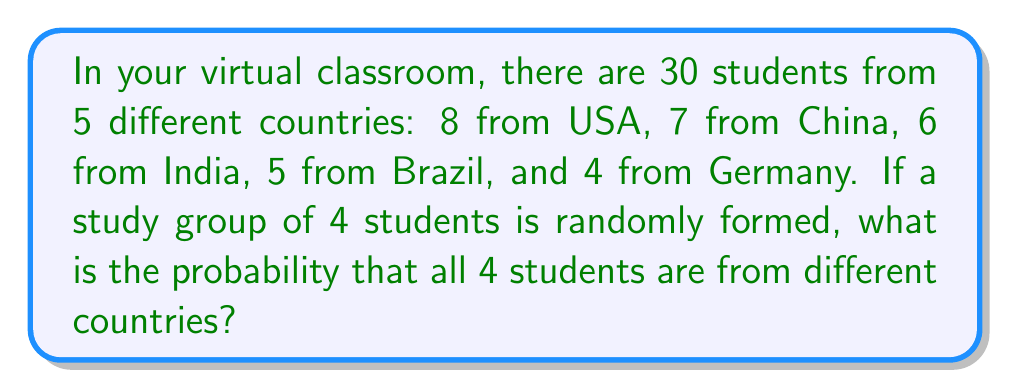Provide a solution to this math problem. Let's approach this step-by-step:

1) First, we need to calculate the total number of ways to choose 4 students out of 30. This is given by the combination formula:

   $$\binom{30}{4} = \frac{30!}{4!(30-4)!} = \frac{30!}{4!26!} = 27405$$

2) Now, we need to calculate the number of ways to choose 4 students from 4 different countries. We can do this as follows:
   - Choose 1 student from USA: $\binom{8}{1}$
   - Choose 1 student from China: $\binom{7}{1}$
   - Choose 1 student from India: $\binom{6}{1}$
   - Choose 1 student from either Brazil or Germany: $\binom{5}{1} + \binom{4}{1}$

3) Multiply these together and then multiply by the number of ways to arrange 4 students (4!):

   $$8 \cdot 7 \cdot 6 \cdot (5+4) \cdot 4! = 8 \cdot 7 \cdot 6 \cdot 9 \cdot 24 = 72576$$

4) The probability is then the number of favorable outcomes divided by the total number of possible outcomes:

   $$P(\text{4 students from different countries}) = \frac{72576}{27405} = \frac{8064}{3045} \approx 0.2648$$
Answer: $\frac{8064}{3045}$ 